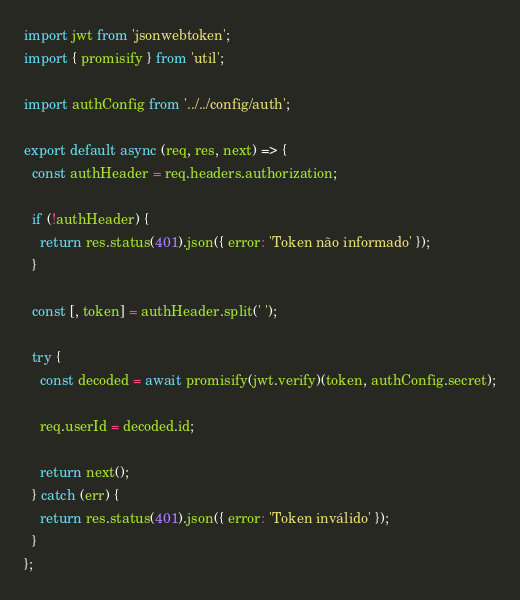Convert code to text. <code><loc_0><loc_0><loc_500><loc_500><_JavaScript_>import jwt from 'jsonwebtoken';
import { promisify } from 'util';

import authConfig from '../../config/auth';

export default async (req, res, next) => {
  const authHeader = req.headers.authorization;

  if (!authHeader) {
    return res.status(401).json({ error: 'Token não informado' });
  }

  const [, token] = authHeader.split(' ');

  try {
    const decoded = await promisify(jwt.verify)(token, authConfig.secret);

    req.userId = decoded.id;

    return next();
  } catch (err) {
    return res.status(401).json({ error: 'Token inválido' });
  }
};
</code> 